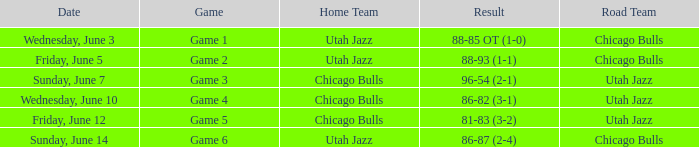Result of 86-87 (2-4) involves what home team? Utah Jazz. 